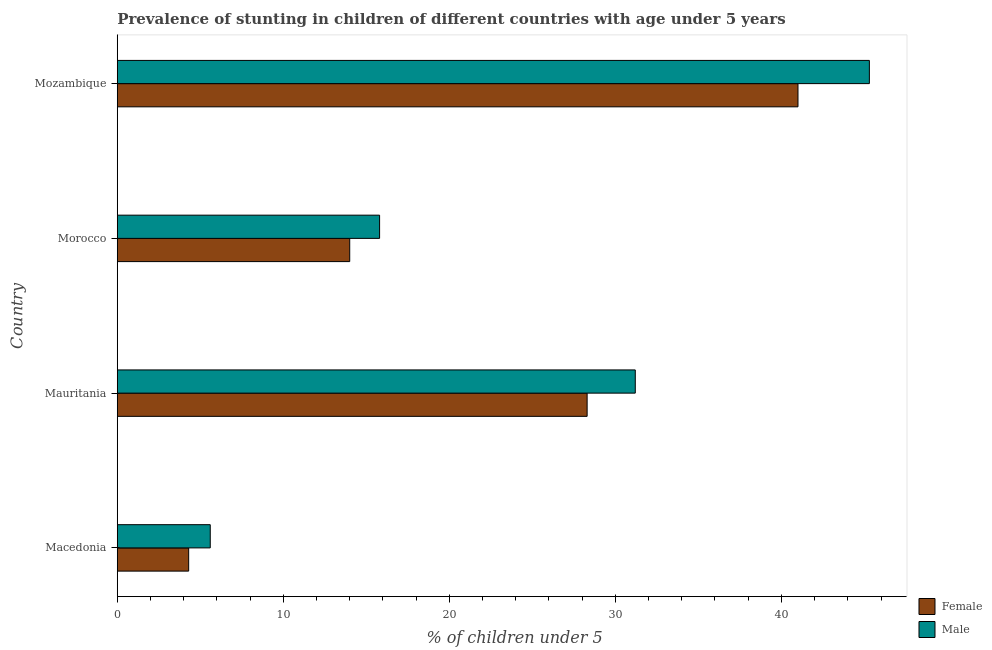How many different coloured bars are there?
Your response must be concise. 2. Are the number of bars per tick equal to the number of legend labels?
Your answer should be very brief. Yes. Are the number of bars on each tick of the Y-axis equal?
Ensure brevity in your answer.  Yes. How many bars are there on the 2nd tick from the top?
Your response must be concise. 2. What is the label of the 4th group of bars from the top?
Your answer should be very brief. Macedonia. What is the percentage of stunted female children in Mauritania?
Make the answer very short. 28.3. Across all countries, what is the maximum percentage of stunted male children?
Offer a terse response. 45.3. Across all countries, what is the minimum percentage of stunted female children?
Give a very brief answer. 4.3. In which country was the percentage of stunted female children maximum?
Your answer should be very brief. Mozambique. In which country was the percentage of stunted male children minimum?
Provide a succinct answer. Macedonia. What is the total percentage of stunted male children in the graph?
Give a very brief answer. 97.9. What is the difference between the percentage of stunted male children in Macedonia and that in Mozambique?
Your answer should be compact. -39.7. What is the difference between the percentage of stunted female children in Mozambique and the percentage of stunted male children in Mauritania?
Keep it short and to the point. 9.8. What is the average percentage of stunted female children per country?
Offer a very short reply. 21.9. What is the difference between the percentage of stunted male children and percentage of stunted female children in Morocco?
Give a very brief answer. 1.8. In how many countries, is the percentage of stunted female children greater than 14 %?
Your answer should be compact. 2. What is the ratio of the percentage of stunted female children in Macedonia to that in Mozambique?
Your response must be concise. 0.1. What is the difference between the highest and the lowest percentage of stunted female children?
Provide a succinct answer. 36.7. Is the sum of the percentage of stunted female children in Macedonia and Mauritania greater than the maximum percentage of stunted male children across all countries?
Your answer should be very brief. No. Are all the bars in the graph horizontal?
Your answer should be compact. Yes. How many countries are there in the graph?
Offer a very short reply. 4. What is the difference between two consecutive major ticks on the X-axis?
Provide a succinct answer. 10. Does the graph contain any zero values?
Give a very brief answer. No. How many legend labels are there?
Make the answer very short. 2. How are the legend labels stacked?
Your answer should be compact. Vertical. What is the title of the graph?
Provide a short and direct response. Prevalence of stunting in children of different countries with age under 5 years. Does "Girls" appear as one of the legend labels in the graph?
Your response must be concise. No. What is the label or title of the X-axis?
Give a very brief answer.  % of children under 5. What is the label or title of the Y-axis?
Keep it short and to the point. Country. What is the  % of children under 5 in Female in Macedonia?
Provide a short and direct response. 4.3. What is the  % of children under 5 of Male in Macedonia?
Give a very brief answer. 5.6. What is the  % of children under 5 in Female in Mauritania?
Give a very brief answer. 28.3. What is the  % of children under 5 of Male in Mauritania?
Your response must be concise. 31.2. What is the  % of children under 5 of Female in Morocco?
Give a very brief answer. 14. What is the  % of children under 5 of Male in Morocco?
Ensure brevity in your answer.  15.8. What is the  % of children under 5 of Female in Mozambique?
Offer a terse response. 41. What is the  % of children under 5 in Male in Mozambique?
Your response must be concise. 45.3. Across all countries, what is the maximum  % of children under 5 of Female?
Your answer should be very brief. 41. Across all countries, what is the maximum  % of children under 5 in Male?
Offer a very short reply. 45.3. Across all countries, what is the minimum  % of children under 5 in Female?
Give a very brief answer. 4.3. Across all countries, what is the minimum  % of children under 5 of Male?
Provide a succinct answer. 5.6. What is the total  % of children under 5 of Female in the graph?
Offer a very short reply. 87.6. What is the total  % of children under 5 in Male in the graph?
Ensure brevity in your answer.  97.9. What is the difference between the  % of children under 5 of Female in Macedonia and that in Mauritania?
Provide a short and direct response. -24. What is the difference between the  % of children under 5 of Male in Macedonia and that in Mauritania?
Your answer should be very brief. -25.6. What is the difference between the  % of children under 5 in Male in Macedonia and that in Morocco?
Offer a terse response. -10.2. What is the difference between the  % of children under 5 in Female in Macedonia and that in Mozambique?
Offer a very short reply. -36.7. What is the difference between the  % of children under 5 of Male in Macedonia and that in Mozambique?
Your answer should be very brief. -39.7. What is the difference between the  % of children under 5 of Female in Mauritania and that in Morocco?
Your answer should be compact. 14.3. What is the difference between the  % of children under 5 of Male in Mauritania and that in Mozambique?
Make the answer very short. -14.1. What is the difference between the  % of children under 5 of Female in Morocco and that in Mozambique?
Offer a very short reply. -27. What is the difference between the  % of children under 5 of Male in Morocco and that in Mozambique?
Make the answer very short. -29.5. What is the difference between the  % of children under 5 of Female in Macedonia and the  % of children under 5 of Male in Mauritania?
Keep it short and to the point. -26.9. What is the difference between the  % of children under 5 in Female in Macedonia and the  % of children under 5 in Male in Mozambique?
Ensure brevity in your answer.  -41. What is the difference between the  % of children under 5 of Female in Mauritania and the  % of children under 5 of Male in Morocco?
Provide a succinct answer. 12.5. What is the difference between the  % of children under 5 of Female in Mauritania and the  % of children under 5 of Male in Mozambique?
Keep it short and to the point. -17. What is the difference between the  % of children under 5 of Female in Morocco and the  % of children under 5 of Male in Mozambique?
Keep it short and to the point. -31.3. What is the average  % of children under 5 in Female per country?
Offer a very short reply. 21.9. What is the average  % of children under 5 of Male per country?
Offer a very short reply. 24.48. What is the ratio of the  % of children under 5 of Female in Macedonia to that in Mauritania?
Provide a short and direct response. 0.15. What is the ratio of the  % of children under 5 in Male in Macedonia to that in Mauritania?
Offer a very short reply. 0.18. What is the ratio of the  % of children under 5 of Female in Macedonia to that in Morocco?
Offer a terse response. 0.31. What is the ratio of the  % of children under 5 in Male in Macedonia to that in Morocco?
Your answer should be compact. 0.35. What is the ratio of the  % of children under 5 in Female in Macedonia to that in Mozambique?
Your response must be concise. 0.1. What is the ratio of the  % of children under 5 of Male in Macedonia to that in Mozambique?
Keep it short and to the point. 0.12. What is the ratio of the  % of children under 5 of Female in Mauritania to that in Morocco?
Provide a succinct answer. 2.02. What is the ratio of the  % of children under 5 of Male in Mauritania to that in Morocco?
Keep it short and to the point. 1.97. What is the ratio of the  % of children under 5 of Female in Mauritania to that in Mozambique?
Ensure brevity in your answer.  0.69. What is the ratio of the  % of children under 5 in Male in Mauritania to that in Mozambique?
Your answer should be very brief. 0.69. What is the ratio of the  % of children under 5 of Female in Morocco to that in Mozambique?
Your answer should be very brief. 0.34. What is the ratio of the  % of children under 5 of Male in Morocco to that in Mozambique?
Keep it short and to the point. 0.35. What is the difference between the highest and the second highest  % of children under 5 of Female?
Your answer should be very brief. 12.7. What is the difference between the highest and the second highest  % of children under 5 of Male?
Give a very brief answer. 14.1. What is the difference between the highest and the lowest  % of children under 5 in Female?
Offer a terse response. 36.7. What is the difference between the highest and the lowest  % of children under 5 of Male?
Your response must be concise. 39.7. 